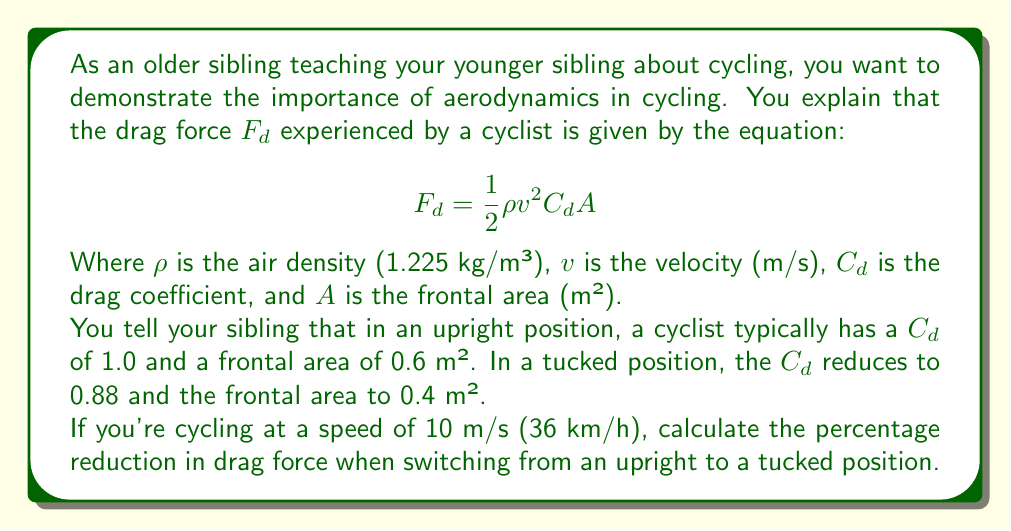Help me with this question. To solve this problem, we need to calculate the drag force for both positions and then find the percentage reduction. Let's break it down step-by-step:

1. Calculate the drag force for the upright position:
   $$F_{d1} = \frac{1}{2} \cdot 1.225 \cdot 10^2 \cdot 1.0 \cdot 0.6$$
   $$F_{d1} = 36.75 \text{ N}$$

2. Calculate the drag force for the tucked position:
   $$F_{d2} = \frac{1}{2} \cdot 1.225 \cdot 10^2 \cdot 0.88 \cdot 0.4$$
   $$F_{d2} = 21.56 \text{ N}$$

3. Calculate the difference in drag force:
   $$\Delta F_d = F_{d1} - F_{d2} = 36.75 - 21.56 = 15.19 \text{ N}$$

4. Calculate the percentage reduction:
   $$\text{Percentage Reduction} = \frac{\Delta F_d}{F_{d1}} \cdot 100\%$$
   $$\text{Percentage Reduction} = \frac{15.19}{36.75} \cdot 100\% = 41.33\%$$

Thus, switching from an upright to a tucked position reduces the drag force by approximately 41.33%.
Answer: 41.33% 